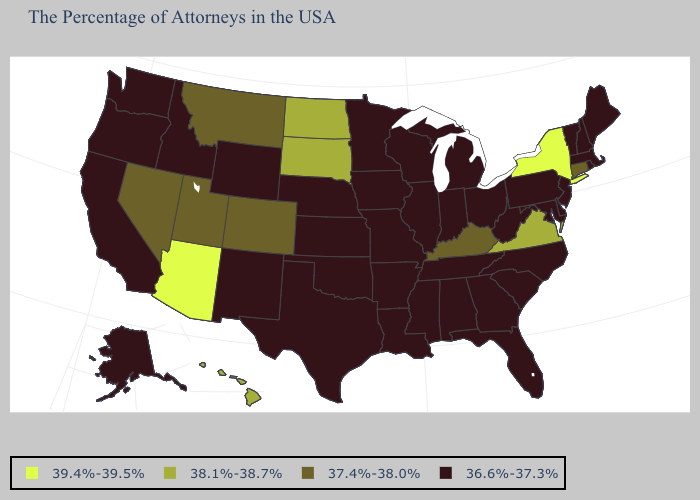Among the states that border Vermont , which have the highest value?
Answer briefly. New York. Name the states that have a value in the range 38.1%-38.7%?
Write a very short answer. Virginia, South Dakota, North Dakota, Hawaii. Among the states that border Nebraska , which have the highest value?
Give a very brief answer. South Dakota. What is the value of Maine?
Short answer required. 36.6%-37.3%. What is the value of New Jersey?
Concise answer only. 36.6%-37.3%. Does the map have missing data?
Answer briefly. No. Among the states that border Massachusetts , does Connecticut have the lowest value?
Concise answer only. No. What is the value of Indiana?
Keep it brief. 36.6%-37.3%. Does Utah have the lowest value in the West?
Be succinct. No. What is the highest value in states that border Minnesota?
Write a very short answer. 38.1%-38.7%. Does the first symbol in the legend represent the smallest category?
Answer briefly. No. Name the states that have a value in the range 37.4%-38.0%?
Give a very brief answer. Connecticut, Kentucky, Colorado, Utah, Montana, Nevada. What is the lowest value in the MidWest?
Be succinct. 36.6%-37.3%. What is the value of North Dakota?
Write a very short answer. 38.1%-38.7%. 